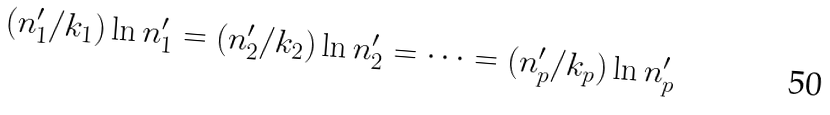Convert formula to latex. <formula><loc_0><loc_0><loc_500><loc_500>( n ^ { \prime } _ { 1 } / k _ { 1 } ) \ln n ^ { \prime } _ { 1 } = ( n ^ { \prime } _ { 2 } / k _ { 2 } ) \ln n ^ { \prime } _ { 2 } = \cdots = ( n _ { p } ^ { \prime } / k _ { p } ) \ln n ^ { \prime } _ { p }</formula> 